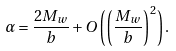Convert formula to latex. <formula><loc_0><loc_0><loc_500><loc_500>\alpha = \frac { 2 M _ { w } } { b } + O \left ( \left ( \frac { M _ { w } } { b } \right ) ^ { 2 } \right ) .</formula> 